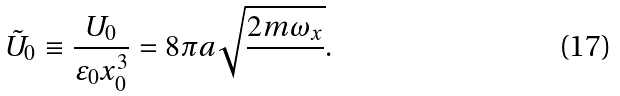<formula> <loc_0><loc_0><loc_500><loc_500>\tilde { U } _ { 0 } \equiv \frac { U _ { 0 } } { \varepsilon _ { 0 } x _ { 0 } ^ { 3 } } = 8 \pi a \sqrt { \frac { 2 m \omega _ { x } } { } } .</formula> 